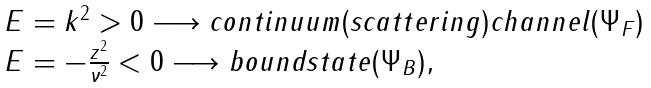<formula> <loc_0><loc_0><loc_500><loc_500>\begin{array} { l } E = k ^ { 2 } > 0 \longrightarrow c o n t i n u u m ( s c a t t e r i n g ) c h a n n e l ( \Psi _ { F } ) \\ E = - \frac { z ^ { 2 } } { \nu ^ { 2 } } < 0 \longrightarrow b o u n d s t a t e ( \Psi _ { B } ) , \end{array}</formula> 